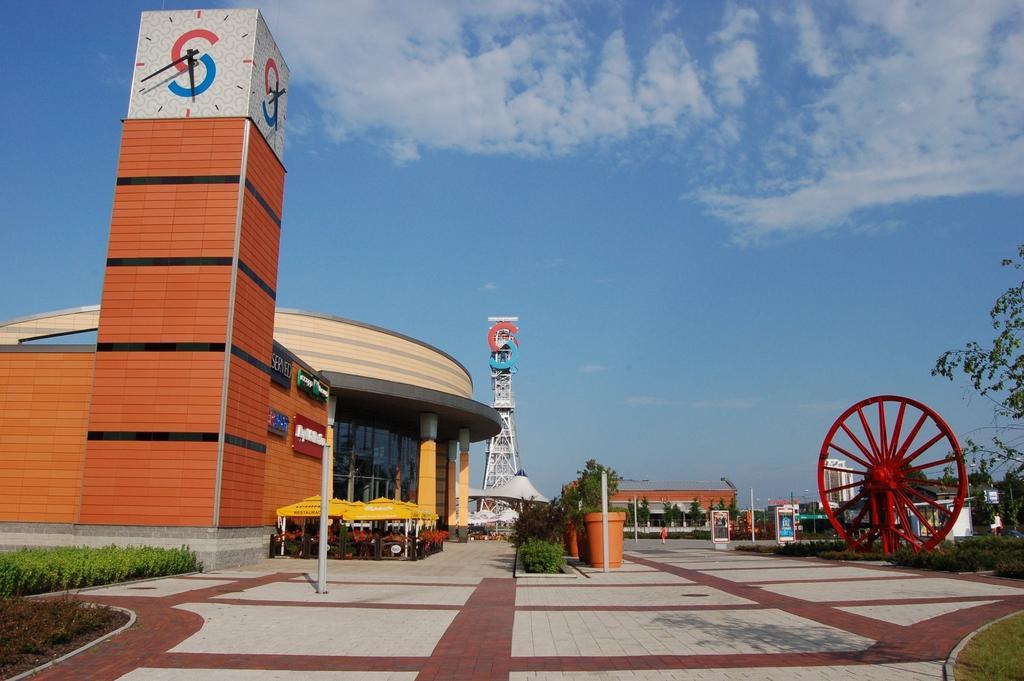In one or two sentences, can you explain what this image depicts? In this picture I can see buildings, a tower and few boards with some text and I can see couple of clocks, few plants, trees and few plants in the pots. I can see few poles, a wheel on the right side and a blue cloudy sky. 